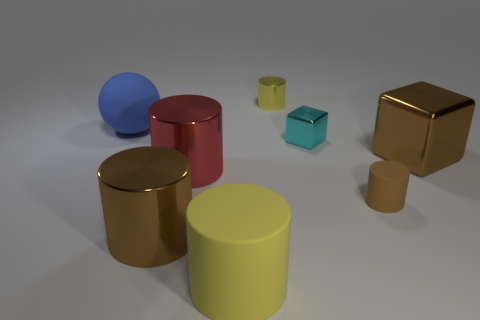What number of things are shiny blocks or brown shiny cylinders?
Offer a terse response. 3. What color is the sphere that is the same size as the yellow matte object?
Make the answer very short. Blue. How many things are either things behind the large blue rubber thing or matte objects?
Your response must be concise. 4. How many other things are the same size as the red cylinder?
Offer a very short reply. 4. There is a cylinder that is to the right of the small cyan shiny object; what is its size?
Your answer should be compact. Small. What shape is the large yellow object that is the same material as the tiny brown cylinder?
Your response must be concise. Cylinder. Are there any other things of the same color as the small cube?
Offer a very short reply. No. The small object in front of the large brown block right of the large matte cylinder is what color?
Provide a succinct answer. Brown. What number of small objects are either gray cylinders or brown metal cubes?
Provide a succinct answer. 0. What material is the large brown object that is the same shape as the big yellow matte object?
Your answer should be very brief. Metal. 